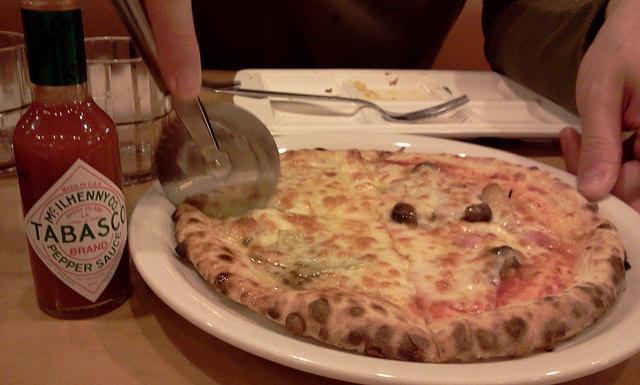How many cups are there?
Give a very brief answer. 2. How many black horses are in the image?
Give a very brief answer. 0. 